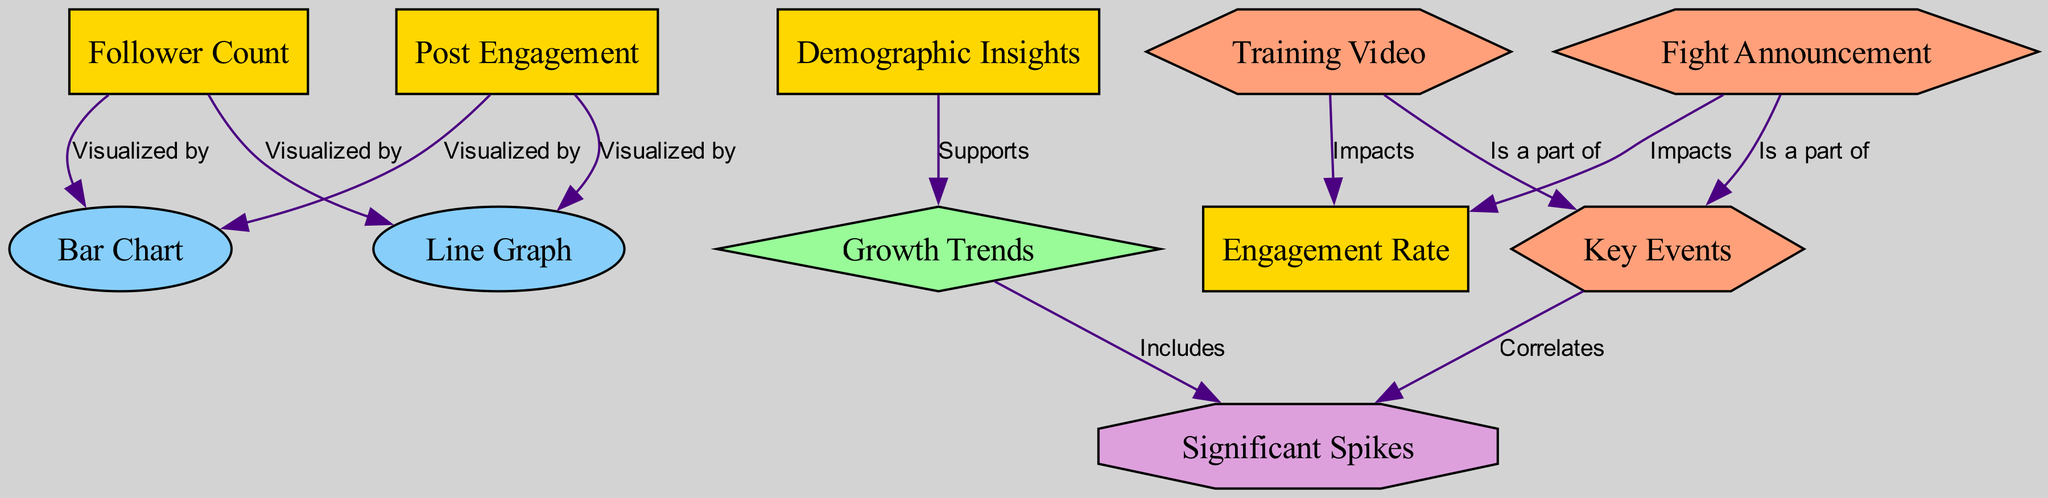What are the two metrics visualized by the bar chart? The bar chart visualizes two metrics, follower count and post engagement, as indicated by the edges connecting these nodes to the bar chart node.
Answer: Follower Count, Post Engagement How many events are connected to key events? There are two events connected to the key events node, which are the fight announcement and training video, as seen in the edges linking these nodes to key events.
Answer: Two What impacts the engagement rate according to the diagram? Both the fight announcement and training video impact the engagement rate, as indicated by the edges from these event nodes to the engagement rate node.
Answer: Fight Announcement, Training Video Which metric supports the growth trends? The demographic insights metric supports the growth trends, as shown by the edge from the demographic insights node to the growth trends node.
Answer: Demographic Insights What type of analysis includes significant spikes? The growth trends include significant spikes, as reflected by the edge from growth trends to significant spikes in the diagram.
Answer: Growth Trends How does the fight announcement relate to significant spikes? The fight announcement correlates with significant spikes, as indicated by the edge connecting the fight announcement node to the significant spikes analysis.
Answer: Correlates What visualizations represent follower count over time? Follower count is represented over time by both the bar chart and the line graph, as indicated by the edges connecting the follower count node to both visualizations.
Answer: Bar Chart, Line Graph How does the demographic insights influence growth trends? The demographic insights support growth trends, as shown by the direct link from the demographic insights node to the growth trends node, indicating a supportive relationship.
Answer: Supports 